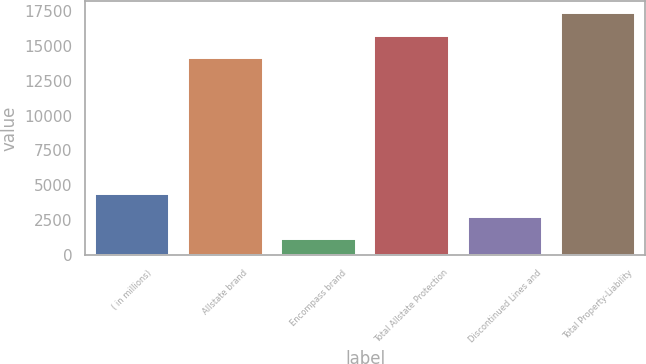Convert chart. <chart><loc_0><loc_0><loc_500><loc_500><bar_chart><fcel>( in millions)<fcel>Allstate brand<fcel>Encompass brand<fcel>Total Allstate Protection<fcel>Discontinued Lines and<fcel>Total Property-Liability<nl><fcel>4342.8<fcel>14118<fcel>1133<fcel>15722.9<fcel>2737.9<fcel>17327.8<nl></chart> 